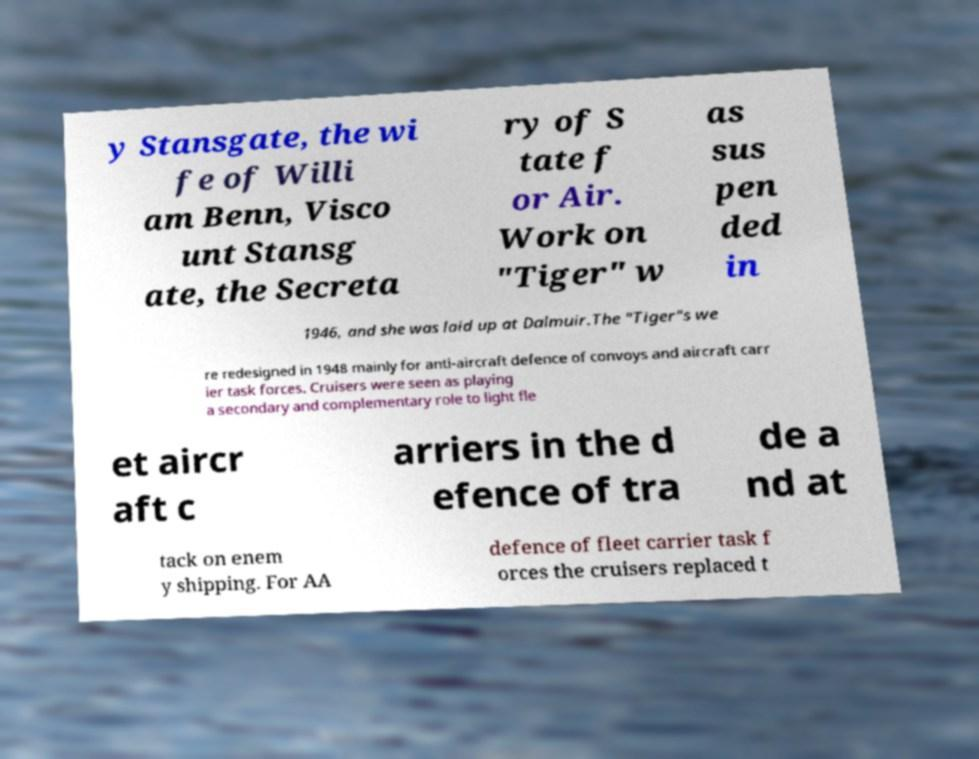Can you read and provide the text displayed in the image?This photo seems to have some interesting text. Can you extract and type it out for me? y Stansgate, the wi fe of Willi am Benn, Visco unt Stansg ate, the Secreta ry of S tate f or Air. Work on "Tiger" w as sus pen ded in 1946, and she was laid up at Dalmuir.The "Tiger"s we re redesigned in 1948 mainly for anti-aircraft defence of convoys and aircraft carr ier task forces. Cruisers were seen as playing a secondary and complementary role to light fle et aircr aft c arriers in the d efence of tra de a nd at tack on enem y shipping. For AA defence of fleet carrier task f orces the cruisers replaced t 